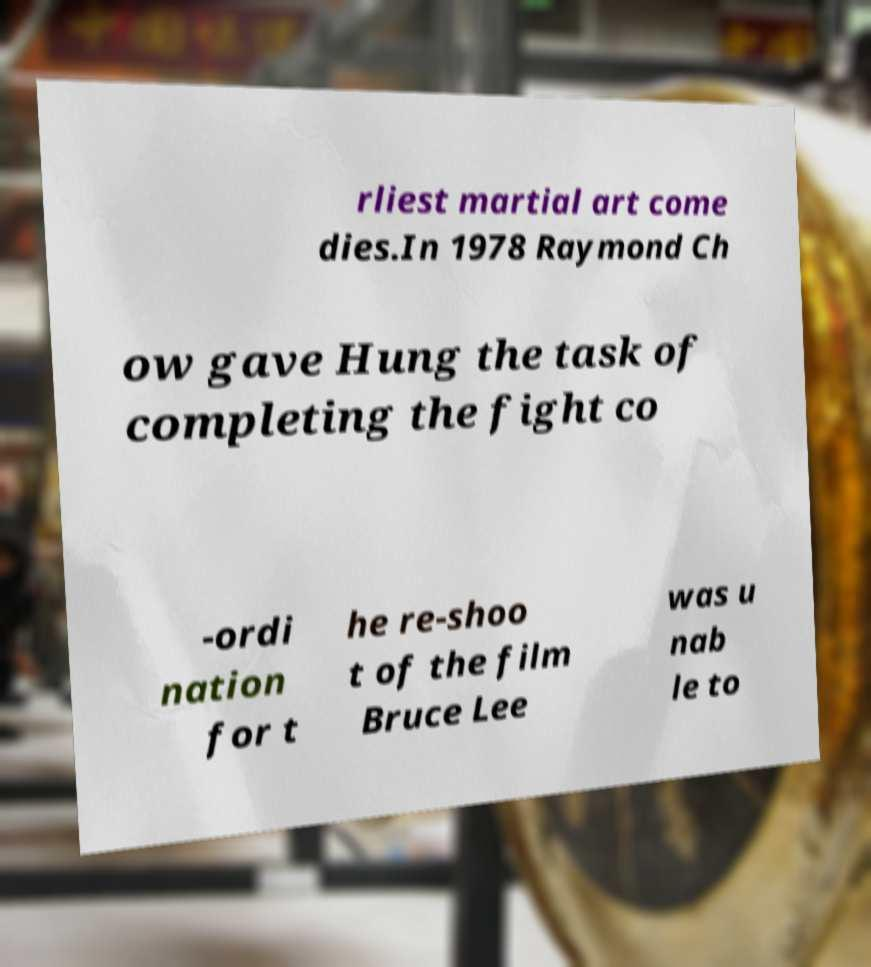Could you assist in decoding the text presented in this image and type it out clearly? rliest martial art come dies.In 1978 Raymond Ch ow gave Hung the task of completing the fight co -ordi nation for t he re-shoo t of the film Bruce Lee was u nab le to 